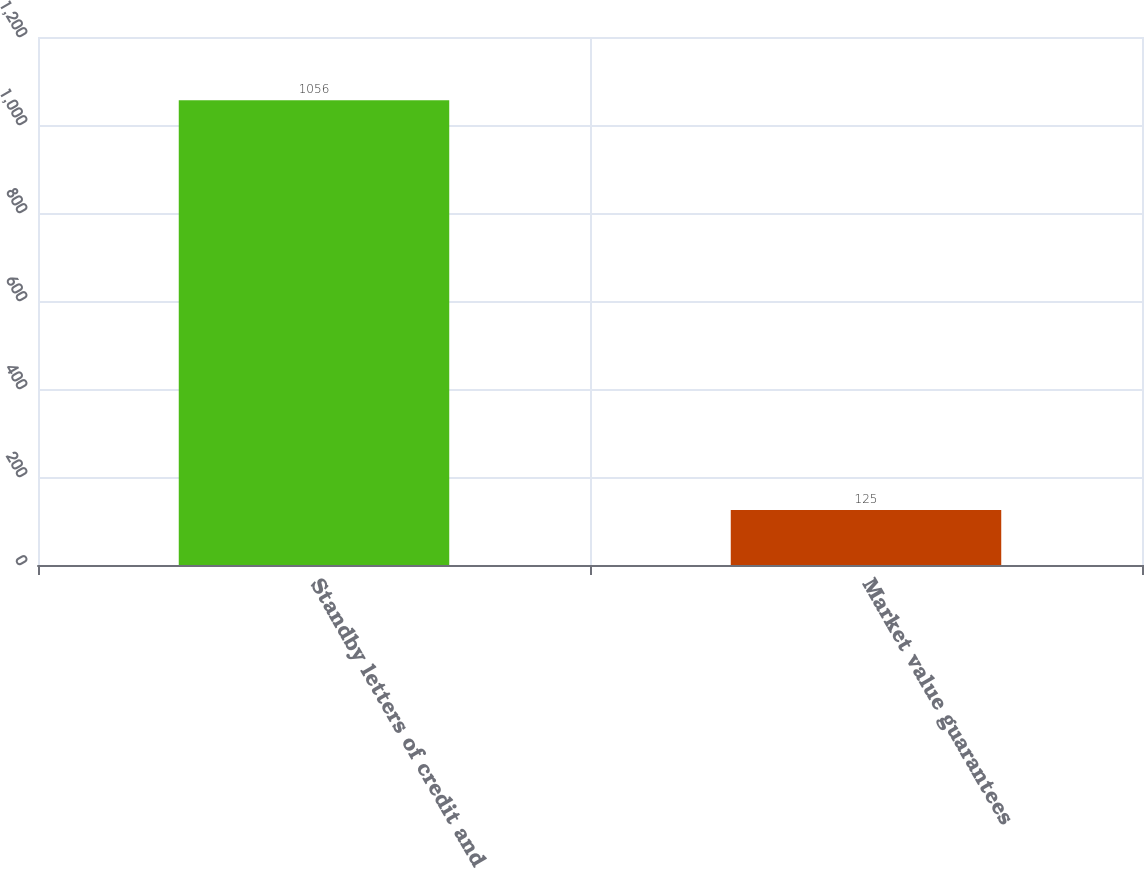Convert chart. <chart><loc_0><loc_0><loc_500><loc_500><bar_chart><fcel>Standby letters of credit and<fcel>Market value guarantees<nl><fcel>1056<fcel>125<nl></chart> 